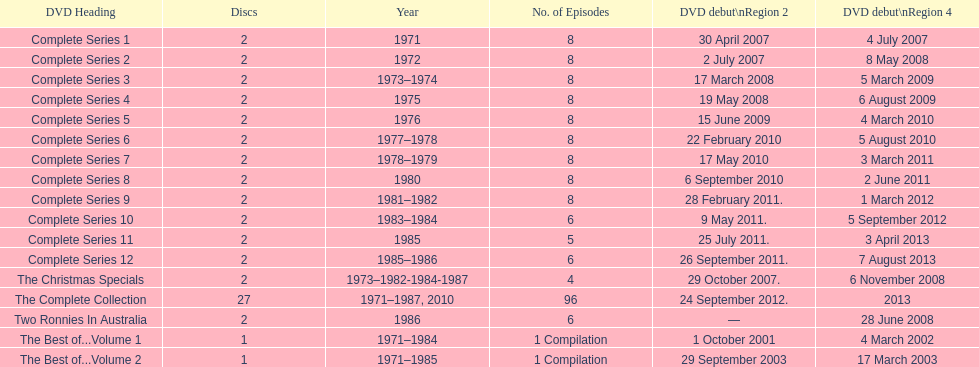The complete collection has 96 episodes, but the christmas specials only has how many episodes? 4. 